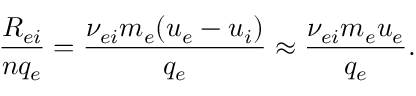<formula> <loc_0><loc_0><loc_500><loc_500>\frac { R _ { e i } } { n q _ { e } } = \frac { \nu _ { e i } m _ { e } ( u _ { e } - u _ { i } ) } { q _ { e } } \approx \frac { \nu _ { e i } m _ { e } u _ { e } } { q _ { e } } .</formula> 